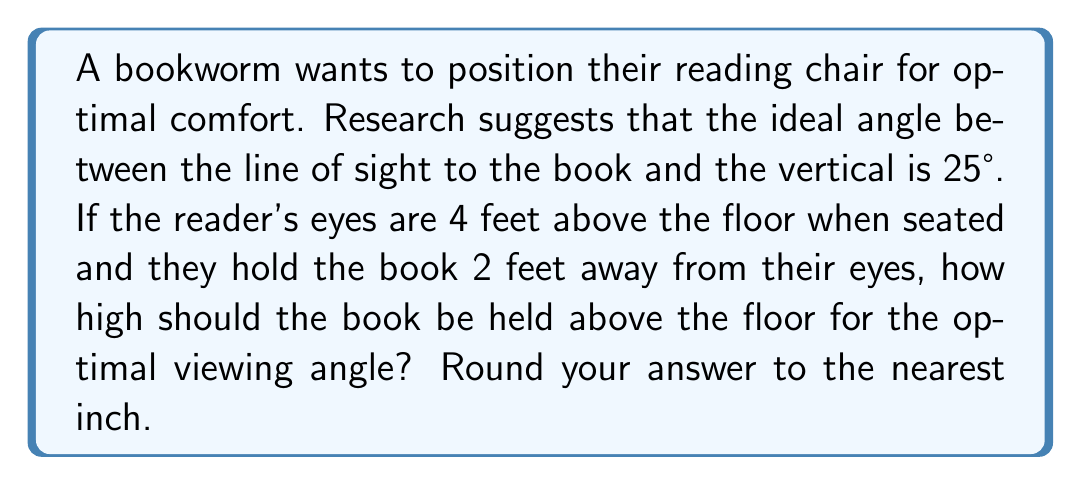Teach me how to tackle this problem. Let's approach this step-by-step using trigonometry:

1) First, let's visualize the problem:
   [asy]
   import geometry;
   
   size(200);
   
   pair A = (0,0);
   pair B = (2,0);
   pair C = (0,4);
   
   draw(A--B--C--cycle);
   
   label("Floor", (1,-0.2), S);
   label("2 ft", (1,0), N);
   label("4 ft", (-0.2,2), W);
   label("Book", B, E);
   label("Eyes", C, N);
   label("25°", (0.3,3.7), NW);
   
   draw(arc(C,0.5,270,295),Arrow);
   [/asy]

2) We're dealing with a right-angled triangle. We know:
   - The adjacent side (vertical distance from eyes to book) = 4 - h, where h is the height of the book
   - The opposite side (horizontal distance from eyes to book) = 2 feet
   - The angle between the line of sight and the vertical = 25°

3) We can use the tangent function:

   $$\tan 25° = \frac{\text{opposite}}{\text{adjacent}} = \frac{2}{4-h}$$

4) Solving for h:
   $$\tan 25° = \frac{2}{4-h}$$
   $$4-h = \frac{2}{\tan 25°}$$
   $$h = 4 - \frac{2}{\tan 25°}$$

5) Let's calculate:
   $$h = 4 - \frac{2}{\tan 25°}$$
   $$h \approx 4 - 4.2799 = -0.2799 \text{ feet}$$

6) Converting to inches:
   $$-0.2799 \text{ feet} \times 12 \text{ inches/foot} \approx -3.36 \text{ inches}$$

7) This means the book should be held 3.36 inches below the 4-foot eye level.

8) Therefore, the height of the book above the floor is:
   $$4 \text{ feet} - 3.36 \text{ inches} = 3 \text{ feet } 8.64 \text{ inches}$$

9) Rounding to the nearest inch:
   $$3 \text{ feet } 9 \text{ inches} = 45 \text{ inches}$$
Answer: 45 inches 